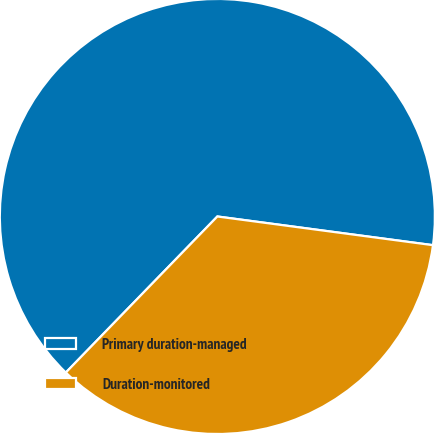<chart> <loc_0><loc_0><loc_500><loc_500><pie_chart><fcel>Primary duration-managed<fcel>Duration-monitored<nl><fcel>64.84%<fcel>35.16%<nl></chart> 